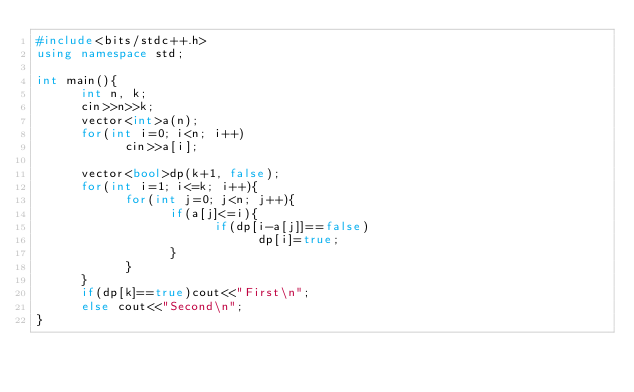Convert code to text. <code><loc_0><loc_0><loc_500><loc_500><_C++_>#include<bits/stdc++.h>
using namespace std;

int main(){
      int n, k;
      cin>>n>>k;
      vector<int>a(n);
      for(int i=0; i<n; i++)
            cin>>a[i];

      vector<bool>dp(k+1, false);
      for(int i=1; i<=k; i++){
            for(int j=0; j<n; j++){
                  if(a[j]<=i){
                        if(dp[i-a[j]]==false)
                              dp[i]=true;
                  }
            }
      }
      if(dp[k]==true)cout<<"First\n";
      else cout<<"Second\n";
}</code> 